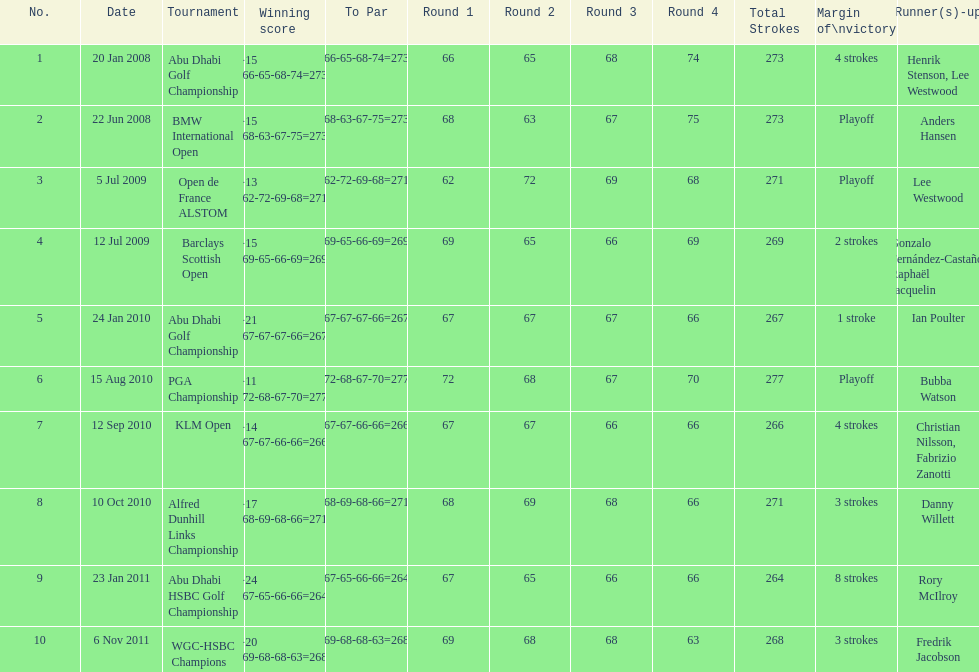How many more strokes were in the klm open than the barclays scottish open? 2 strokes. I'm looking to parse the entire table for insights. Could you assist me with that? {'header': ['No.', 'Date', 'Tournament', 'Winning score', 'To Par', 'Round 1', 'Round 2', 'Round 3', 'Round 4', 'Total Strokes', 'Margin of\\nvictory', 'Runner(s)-up'], 'rows': [['1', '20 Jan 2008', 'Abu Dhabi Golf Championship', '−15 (66-65-68-74=273)', '(66-65-68-74=273)', '66', '65', '68', '74', '273', '4 strokes', 'Henrik Stenson, Lee Westwood'], ['2', '22 Jun 2008', 'BMW International Open', '−15 (68-63-67-75=273)', '(68-63-67-75=273)', '68', '63', '67', '75', '273', 'Playoff', 'Anders Hansen'], ['3', '5 Jul 2009', 'Open de France ALSTOM', '−13 (62-72-69-68=271)', '(62-72-69-68=271)', '62', '72', '69', '68', '271', 'Playoff', 'Lee Westwood'], ['4', '12 Jul 2009', 'Barclays Scottish Open', '−15 (69-65-66-69=269)', '(69-65-66-69=269)', '69', '65', '66', '69', '269', '2 strokes', 'Gonzalo Fernández-Castaño, Raphaël Jacquelin'], ['5', '24 Jan 2010', 'Abu Dhabi Golf Championship', '−21 (67-67-67-66=267)', '(67-67-67-66=267)', '67', '67', '67', '66', '267', '1 stroke', 'Ian Poulter'], ['6', '15 Aug 2010', 'PGA Championship', '−11 (72-68-67-70=277)', '(72-68-67-70=277)', '72', '68', '67', '70', '277', 'Playoff', 'Bubba Watson'], ['7', '12 Sep 2010', 'KLM Open', '−14 (67-67-66-66=266)', '(67-67-66-66=266)', '67', '67', '66', '66', '266', '4 strokes', 'Christian Nilsson, Fabrizio Zanotti'], ['8', '10 Oct 2010', 'Alfred Dunhill Links Championship', '−17 (68-69-68-66=271)', '(68-69-68-66=271)', '68', '69', '68', '66', '271', '3 strokes', 'Danny Willett'], ['9', '23 Jan 2011', 'Abu Dhabi HSBC Golf Championship', '−24 (67-65-66-66=264)', '(67-65-66-66=264)', '67', '65', '66', '66', '264', '8 strokes', 'Rory McIlroy'], ['10', '6 Nov 2011', 'WGC-HSBC Champions', '−20 (69-68-68-63=268)', '(69-68-68-63=268)', '69', '68', '68', '63', '268', '3 strokes', 'Fredrik Jacobson']]} 